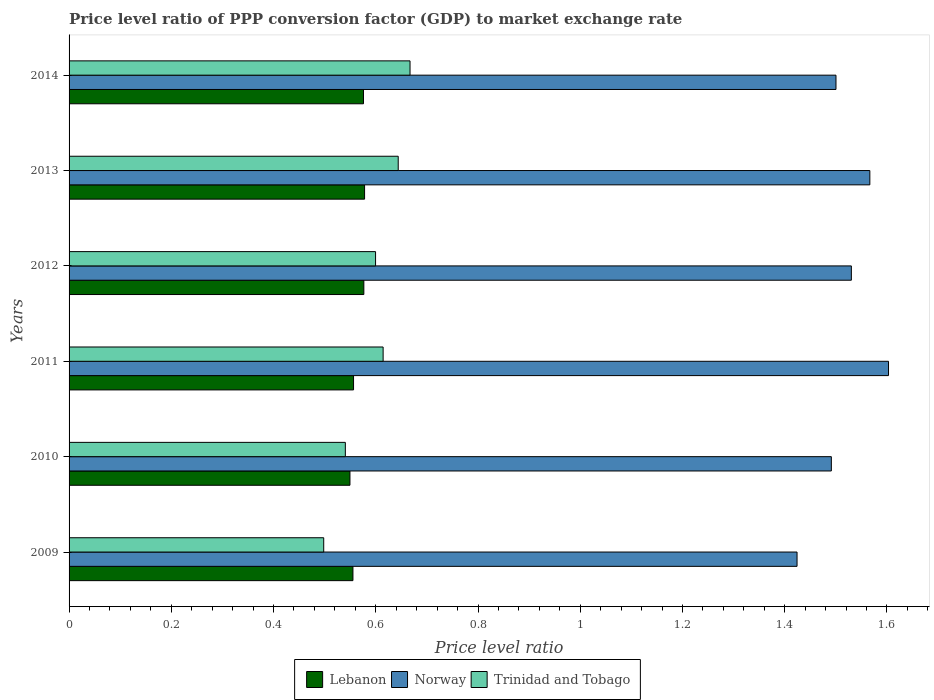How many different coloured bars are there?
Offer a very short reply. 3. How many bars are there on the 4th tick from the top?
Offer a very short reply. 3. How many bars are there on the 1st tick from the bottom?
Offer a terse response. 3. In how many cases, is the number of bars for a given year not equal to the number of legend labels?
Give a very brief answer. 0. What is the price level ratio in Norway in 2011?
Provide a short and direct response. 1.6. Across all years, what is the maximum price level ratio in Norway?
Give a very brief answer. 1.6. Across all years, what is the minimum price level ratio in Norway?
Provide a succinct answer. 1.42. What is the total price level ratio in Lebanon in the graph?
Offer a very short reply. 3.39. What is the difference between the price level ratio in Trinidad and Tobago in 2009 and that in 2012?
Keep it short and to the point. -0.1. What is the difference between the price level ratio in Norway in 2010 and the price level ratio in Trinidad and Tobago in 2012?
Ensure brevity in your answer.  0.89. What is the average price level ratio in Lebanon per year?
Your answer should be very brief. 0.57. In the year 2014, what is the difference between the price level ratio in Norway and price level ratio in Lebanon?
Keep it short and to the point. 0.92. In how many years, is the price level ratio in Norway greater than 1.36 ?
Your response must be concise. 6. What is the ratio of the price level ratio in Norway in 2009 to that in 2013?
Provide a succinct answer. 0.91. Is the price level ratio in Norway in 2009 less than that in 2014?
Offer a terse response. Yes. What is the difference between the highest and the second highest price level ratio in Norway?
Provide a short and direct response. 0.04. What is the difference between the highest and the lowest price level ratio in Trinidad and Tobago?
Provide a succinct answer. 0.17. What does the 3rd bar from the top in 2012 represents?
Your response must be concise. Lebanon. Is it the case that in every year, the sum of the price level ratio in Norway and price level ratio in Trinidad and Tobago is greater than the price level ratio in Lebanon?
Make the answer very short. Yes. How many bars are there?
Provide a short and direct response. 18. Are all the bars in the graph horizontal?
Give a very brief answer. Yes. How many years are there in the graph?
Make the answer very short. 6. Are the values on the major ticks of X-axis written in scientific E-notation?
Ensure brevity in your answer.  No. Where does the legend appear in the graph?
Offer a very short reply. Bottom center. How are the legend labels stacked?
Your response must be concise. Horizontal. What is the title of the graph?
Keep it short and to the point. Price level ratio of PPP conversion factor (GDP) to market exchange rate. Does "Swaziland" appear as one of the legend labels in the graph?
Offer a very short reply. No. What is the label or title of the X-axis?
Give a very brief answer. Price level ratio. What is the label or title of the Y-axis?
Make the answer very short. Years. What is the Price level ratio of Lebanon in 2009?
Make the answer very short. 0.56. What is the Price level ratio in Norway in 2009?
Ensure brevity in your answer.  1.42. What is the Price level ratio in Trinidad and Tobago in 2009?
Offer a very short reply. 0.5. What is the Price level ratio of Lebanon in 2010?
Provide a succinct answer. 0.55. What is the Price level ratio of Norway in 2010?
Ensure brevity in your answer.  1.49. What is the Price level ratio of Trinidad and Tobago in 2010?
Keep it short and to the point. 0.54. What is the Price level ratio of Lebanon in 2011?
Your response must be concise. 0.56. What is the Price level ratio of Norway in 2011?
Your response must be concise. 1.6. What is the Price level ratio of Trinidad and Tobago in 2011?
Offer a very short reply. 0.61. What is the Price level ratio in Lebanon in 2012?
Your answer should be compact. 0.58. What is the Price level ratio in Norway in 2012?
Offer a terse response. 1.53. What is the Price level ratio in Trinidad and Tobago in 2012?
Your answer should be compact. 0.6. What is the Price level ratio of Lebanon in 2013?
Your answer should be compact. 0.58. What is the Price level ratio in Norway in 2013?
Keep it short and to the point. 1.57. What is the Price level ratio in Trinidad and Tobago in 2013?
Provide a succinct answer. 0.64. What is the Price level ratio of Lebanon in 2014?
Provide a succinct answer. 0.58. What is the Price level ratio of Norway in 2014?
Your answer should be very brief. 1.5. What is the Price level ratio in Trinidad and Tobago in 2014?
Keep it short and to the point. 0.67. Across all years, what is the maximum Price level ratio in Lebanon?
Keep it short and to the point. 0.58. Across all years, what is the maximum Price level ratio of Norway?
Provide a succinct answer. 1.6. Across all years, what is the maximum Price level ratio in Trinidad and Tobago?
Make the answer very short. 0.67. Across all years, what is the minimum Price level ratio in Lebanon?
Ensure brevity in your answer.  0.55. Across all years, what is the minimum Price level ratio in Norway?
Give a very brief answer. 1.42. Across all years, what is the minimum Price level ratio of Trinidad and Tobago?
Make the answer very short. 0.5. What is the total Price level ratio in Lebanon in the graph?
Your answer should be very brief. 3.39. What is the total Price level ratio of Norway in the graph?
Offer a very short reply. 9.12. What is the total Price level ratio of Trinidad and Tobago in the graph?
Provide a short and direct response. 3.56. What is the difference between the Price level ratio of Lebanon in 2009 and that in 2010?
Keep it short and to the point. 0.01. What is the difference between the Price level ratio of Norway in 2009 and that in 2010?
Ensure brevity in your answer.  -0.07. What is the difference between the Price level ratio in Trinidad and Tobago in 2009 and that in 2010?
Keep it short and to the point. -0.04. What is the difference between the Price level ratio in Lebanon in 2009 and that in 2011?
Offer a terse response. -0. What is the difference between the Price level ratio in Norway in 2009 and that in 2011?
Provide a succinct answer. -0.18. What is the difference between the Price level ratio in Trinidad and Tobago in 2009 and that in 2011?
Your response must be concise. -0.12. What is the difference between the Price level ratio of Lebanon in 2009 and that in 2012?
Ensure brevity in your answer.  -0.02. What is the difference between the Price level ratio in Norway in 2009 and that in 2012?
Make the answer very short. -0.11. What is the difference between the Price level ratio in Trinidad and Tobago in 2009 and that in 2012?
Provide a succinct answer. -0.1. What is the difference between the Price level ratio of Lebanon in 2009 and that in 2013?
Provide a succinct answer. -0.02. What is the difference between the Price level ratio of Norway in 2009 and that in 2013?
Offer a terse response. -0.14. What is the difference between the Price level ratio of Trinidad and Tobago in 2009 and that in 2013?
Your answer should be compact. -0.15. What is the difference between the Price level ratio of Lebanon in 2009 and that in 2014?
Your answer should be compact. -0.02. What is the difference between the Price level ratio of Norway in 2009 and that in 2014?
Give a very brief answer. -0.08. What is the difference between the Price level ratio of Trinidad and Tobago in 2009 and that in 2014?
Provide a succinct answer. -0.17. What is the difference between the Price level ratio in Lebanon in 2010 and that in 2011?
Make the answer very short. -0.01. What is the difference between the Price level ratio in Norway in 2010 and that in 2011?
Provide a short and direct response. -0.11. What is the difference between the Price level ratio in Trinidad and Tobago in 2010 and that in 2011?
Offer a terse response. -0.07. What is the difference between the Price level ratio in Lebanon in 2010 and that in 2012?
Keep it short and to the point. -0.03. What is the difference between the Price level ratio of Norway in 2010 and that in 2012?
Give a very brief answer. -0.04. What is the difference between the Price level ratio of Trinidad and Tobago in 2010 and that in 2012?
Ensure brevity in your answer.  -0.06. What is the difference between the Price level ratio of Lebanon in 2010 and that in 2013?
Your answer should be very brief. -0.03. What is the difference between the Price level ratio of Norway in 2010 and that in 2013?
Your answer should be very brief. -0.08. What is the difference between the Price level ratio in Trinidad and Tobago in 2010 and that in 2013?
Make the answer very short. -0.1. What is the difference between the Price level ratio of Lebanon in 2010 and that in 2014?
Offer a very short reply. -0.03. What is the difference between the Price level ratio in Norway in 2010 and that in 2014?
Offer a very short reply. -0.01. What is the difference between the Price level ratio of Trinidad and Tobago in 2010 and that in 2014?
Your answer should be compact. -0.13. What is the difference between the Price level ratio of Lebanon in 2011 and that in 2012?
Provide a short and direct response. -0.02. What is the difference between the Price level ratio of Norway in 2011 and that in 2012?
Offer a very short reply. 0.07. What is the difference between the Price level ratio in Trinidad and Tobago in 2011 and that in 2012?
Your answer should be compact. 0.01. What is the difference between the Price level ratio of Lebanon in 2011 and that in 2013?
Offer a very short reply. -0.02. What is the difference between the Price level ratio of Norway in 2011 and that in 2013?
Your response must be concise. 0.04. What is the difference between the Price level ratio of Trinidad and Tobago in 2011 and that in 2013?
Provide a succinct answer. -0.03. What is the difference between the Price level ratio in Lebanon in 2011 and that in 2014?
Ensure brevity in your answer.  -0.02. What is the difference between the Price level ratio of Norway in 2011 and that in 2014?
Your answer should be very brief. 0.1. What is the difference between the Price level ratio of Trinidad and Tobago in 2011 and that in 2014?
Offer a very short reply. -0.05. What is the difference between the Price level ratio of Lebanon in 2012 and that in 2013?
Your response must be concise. -0. What is the difference between the Price level ratio in Norway in 2012 and that in 2013?
Offer a very short reply. -0.04. What is the difference between the Price level ratio of Trinidad and Tobago in 2012 and that in 2013?
Give a very brief answer. -0.04. What is the difference between the Price level ratio in Lebanon in 2012 and that in 2014?
Keep it short and to the point. 0. What is the difference between the Price level ratio in Norway in 2012 and that in 2014?
Make the answer very short. 0.03. What is the difference between the Price level ratio of Trinidad and Tobago in 2012 and that in 2014?
Keep it short and to the point. -0.07. What is the difference between the Price level ratio of Lebanon in 2013 and that in 2014?
Provide a succinct answer. 0. What is the difference between the Price level ratio of Norway in 2013 and that in 2014?
Offer a terse response. 0.07. What is the difference between the Price level ratio of Trinidad and Tobago in 2013 and that in 2014?
Your response must be concise. -0.02. What is the difference between the Price level ratio of Lebanon in 2009 and the Price level ratio of Norway in 2010?
Provide a succinct answer. -0.94. What is the difference between the Price level ratio of Lebanon in 2009 and the Price level ratio of Trinidad and Tobago in 2010?
Your answer should be very brief. 0.01. What is the difference between the Price level ratio of Norway in 2009 and the Price level ratio of Trinidad and Tobago in 2010?
Provide a succinct answer. 0.88. What is the difference between the Price level ratio in Lebanon in 2009 and the Price level ratio in Norway in 2011?
Provide a succinct answer. -1.05. What is the difference between the Price level ratio in Lebanon in 2009 and the Price level ratio in Trinidad and Tobago in 2011?
Offer a terse response. -0.06. What is the difference between the Price level ratio in Norway in 2009 and the Price level ratio in Trinidad and Tobago in 2011?
Offer a terse response. 0.81. What is the difference between the Price level ratio of Lebanon in 2009 and the Price level ratio of Norway in 2012?
Your response must be concise. -0.98. What is the difference between the Price level ratio of Lebanon in 2009 and the Price level ratio of Trinidad and Tobago in 2012?
Offer a very short reply. -0.04. What is the difference between the Price level ratio in Norway in 2009 and the Price level ratio in Trinidad and Tobago in 2012?
Keep it short and to the point. 0.82. What is the difference between the Price level ratio of Lebanon in 2009 and the Price level ratio of Norway in 2013?
Ensure brevity in your answer.  -1.01. What is the difference between the Price level ratio in Lebanon in 2009 and the Price level ratio in Trinidad and Tobago in 2013?
Offer a terse response. -0.09. What is the difference between the Price level ratio in Norway in 2009 and the Price level ratio in Trinidad and Tobago in 2013?
Your response must be concise. 0.78. What is the difference between the Price level ratio of Lebanon in 2009 and the Price level ratio of Norway in 2014?
Make the answer very short. -0.94. What is the difference between the Price level ratio in Lebanon in 2009 and the Price level ratio in Trinidad and Tobago in 2014?
Your answer should be compact. -0.11. What is the difference between the Price level ratio of Norway in 2009 and the Price level ratio of Trinidad and Tobago in 2014?
Offer a terse response. 0.76. What is the difference between the Price level ratio of Lebanon in 2010 and the Price level ratio of Norway in 2011?
Your response must be concise. -1.05. What is the difference between the Price level ratio of Lebanon in 2010 and the Price level ratio of Trinidad and Tobago in 2011?
Give a very brief answer. -0.06. What is the difference between the Price level ratio in Norway in 2010 and the Price level ratio in Trinidad and Tobago in 2011?
Your answer should be very brief. 0.88. What is the difference between the Price level ratio of Lebanon in 2010 and the Price level ratio of Norway in 2012?
Offer a terse response. -0.98. What is the difference between the Price level ratio of Lebanon in 2010 and the Price level ratio of Trinidad and Tobago in 2012?
Offer a very short reply. -0.05. What is the difference between the Price level ratio of Norway in 2010 and the Price level ratio of Trinidad and Tobago in 2012?
Make the answer very short. 0.89. What is the difference between the Price level ratio of Lebanon in 2010 and the Price level ratio of Norway in 2013?
Make the answer very short. -1.02. What is the difference between the Price level ratio in Lebanon in 2010 and the Price level ratio in Trinidad and Tobago in 2013?
Your response must be concise. -0.09. What is the difference between the Price level ratio in Norway in 2010 and the Price level ratio in Trinidad and Tobago in 2013?
Offer a very short reply. 0.85. What is the difference between the Price level ratio in Lebanon in 2010 and the Price level ratio in Norway in 2014?
Your answer should be compact. -0.95. What is the difference between the Price level ratio of Lebanon in 2010 and the Price level ratio of Trinidad and Tobago in 2014?
Your answer should be compact. -0.12. What is the difference between the Price level ratio in Norway in 2010 and the Price level ratio in Trinidad and Tobago in 2014?
Ensure brevity in your answer.  0.82. What is the difference between the Price level ratio in Lebanon in 2011 and the Price level ratio in Norway in 2012?
Make the answer very short. -0.97. What is the difference between the Price level ratio of Lebanon in 2011 and the Price level ratio of Trinidad and Tobago in 2012?
Your response must be concise. -0.04. What is the difference between the Price level ratio of Lebanon in 2011 and the Price level ratio of Norway in 2013?
Keep it short and to the point. -1.01. What is the difference between the Price level ratio in Lebanon in 2011 and the Price level ratio in Trinidad and Tobago in 2013?
Offer a terse response. -0.09. What is the difference between the Price level ratio in Norway in 2011 and the Price level ratio in Trinidad and Tobago in 2013?
Offer a very short reply. 0.96. What is the difference between the Price level ratio of Lebanon in 2011 and the Price level ratio of Norway in 2014?
Your response must be concise. -0.94. What is the difference between the Price level ratio of Lebanon in 2011 and the Price level ratio of Trinidad and Tobago in 2014?
Your answer should be compact. -0.11. What is the difference between the Price level ratio in Norway in 2011 and the Price level ratio in Trinidad and Tobago in 2014?
Your answer should be compact. 0.94. What is the difference between the Price level ratio of Lebanon in 2012 and the Price level ratio of Norway in 2013?
Your response must be concise. -0.99. What is the difference between the Price level ratio of Lebanon in 2012 and the Price level ratio of Trinidad and Tobago in 2013?
Provide a short and direct response. -0.07. What is the difference between the Price level ratio in Norway in 2012 and the Price level ratio in Trinidad and Tobago in 2013?
Make the answer very short. 0.89. What is the difference between the Price level ratio of Lebanon in 2012 and the Price level ratio of Norway in 2014?
Offer a terse response. -0.92. What is the difference between the Price level ratio of Lebanon in 2012 and the Price level ratio of Trinidad and Tobago in 2014?
Make the answer very short. -0.09. What is the difference between the Price level ratio in Norway in 2012 and the Price level ratio in Trinidad and Tobago in 2014?
Give a very brief answer. 0.86. What is the difference between the Price level ratio of Lebanon in 2013 and the Price level ratio of Norway in 2014?
Your answer should be compact. -0.92. What is the difference between the Price level ratio of Lebanon in 2013 and the Price level ratio of Trinidad and Tobago in 2014?
Give a very brief answer. -0.09. What is the difference between the Price level ratio of Norway in 2013 and the Price level ratio of Trinidad and Tobago in 2014?
Your response must be concise. 0.9. What is the average Price level ratio of Lebanon per year?
Provide a short and direct response. 0.57. What is the average Price level ratio in Norway per year?
Offer a terse response. 1.52. What is the average Price level ratio in Trinidad and Tobago per year?
Keep it short and to the point. 0.59. In the year 2009, what is the difference between the Price level ratio in Lebanon and Price level ratio in Norway?
Your answer should be very brief. -0.87. In the year 2009, what is the difference between the Price level ratio of Lebanon and Price level ratio of Trinidad and Tobago?
Provide a succinct answer. 0.06. In the year 2009, what is the difference between the Price level ratio of Norway and Price level ratio of Trinidad and Tobago?
Your answer should be very brief. 0.93. In the year 2010, what is the difference between the Price level ratio in Lebanon and Price level ratio in Norway?
Offer a very short reply. -0.94. In the year 2010, what is the difference between the Price level ratio in Lebanon and Price level ratio in Trinidad and Tobago?
Your answer should be compact. 0.01. In the year 2010, what is the difference between the Price level ratio of Norway and Price level ratio of Trinidad and Tobago?
Offer a terse response. 0.95. In the year 2011, what is the difference between the Price level ratio in Lebanon and Price level ratio in Norway?
Offer a very short reply. -1.05. In the year 2011, what is the difference between the Price level ratio of Lebanon and Price level ratio of Trinidad and Tobago?
Provide a short and direct response. -0.06. In the year 2011, what is the difference between the Price level ratio of Norway and Price level ratio of Trinidad and Tobago?
Provide a succinct answer. 0.99. In the year 2012, what is the difference between the Price level ratio of Lebanon and Price level ratio of Norway?
Provide a short and direct response. -0.95. In the year 2012, what is the difference between the Price level ratio in Lebanon and Price level ratio in Trinidad and Tobago?
Give a very brief answer. -0.02. In the year 2012, what is the difference between the Price level ratio of Norway and Price level ratio of Trinidad and Tobago?
Your answer should be compact. 0.93. In the year 2013, what is the difference between the Price level ratio of Lebanon and Price level ratio of Norway?
Your response must be concise. -0.99. In the year 2013, what is the difference between the Price level ratio of Lebanon and Price level ratio of Trinidad and Tobago?
Make the answer very short. -0.07. In the year 2013, what is the difference between the Price level ratio of Norway and Price level ratio of Trinidad and Tobago?
Make the answer very short. 0.92. In the year 2014, what is the difference between the Price level ratio in Lebanon and Price level ratio in Norway?
Keep it short and to the point. -0.92. In the year 2014, what is the difference between the Price level ratio in Lebanon and Price level ratio in Trinidad and Tobago?
Ensure brevity in your answer.  -0.09. What is the ratio of the Price level ratio in Lebanon in 2009 to that in 2010?
Your response must be concise. 1.01. What is the ratio of the Price level ratio in Norway in 2009 to that in 2010?
Your response must be concise. 0.95. What is the ratio of the Price level ratio in Trinidad and Tobago in 2009 to that in 2010?
Offer a very short reply. 0.92. What is the ratio of the Price level ratio of Norway in 2009 to that in 2011?
Offer a very short reply. 0.89. What is the ratio of the Price level ratio in Trinidad and Tobago in 2009 to that in 2011?
Keep it short and to the point. 0.81. What is the ratio of the Price level ratio of Lebanon in 2009 to that in 2012?
Your response must be concise. 0.96. What is the ratio of the Price level ratio of Norway in 2009 to that in 2012?
Offer a terse response. 0.93. What is the ratio of the Price level ratio of Trinidad and Tobago in 2009 to that in 2012?
Keep it short and to the point. 0.83. What is the ratio of the Price level ratio in Lebanon in 2009 to that in 2013?
Your answer should be very brief. 0.96. What is the ratio of the Price level ratio in Norway in 2009 to that in 2013?
Offer a very short reply. 0.91. What is the ratio of the Price level ratio of Trinidad and Tobago in 2009 to that in 2013?
Give a very brief answer. 0.77. What is the ratio of the Price level ratio in Lebanon in 2009 to that in 2014?
Ensure brevity in your answer.  0.96. What is the ratio of the Price level ratio in Norway in 2009 to that in 2014?
Keep it short and to the point. 0.95. What is the ratio of the Price level ratio in Trinidad and Tobago in 2009 to that in 2014?
Keep it short and to the point. 0.75. What is the ratio of the Price level ratio in Lebanon in 2010 to that in 2011?
Ensure brevity in your answer.  0.99. What is the ratio of the Price level ratio of Norway in 2010 to that in 2011?
Give a very brief answer. 0.93. What is the ratio of the Price level ratio of Trinidad and Tobago in 2010 to that in 2011?
Make the answer very short. 0.88. What is the ratio of the Price level ratio in Lebanon in 2010 to that in 2012?
Your response must be concise. 0.95. What is the ratio of the Price level ratio of Norway in 2010 to that in 2012?
Keep it short and to the point. 0.97. What is the ratio of the Price level ratio in Trinidad and Tobago in 2010 to that in 2012?
Your answer should be very brief. 0.9. What is the ratio of the Price level ratio in Lebanon in 2010 to that in 2013?
Offer a terse response. 0.95. What is the ratio of the Price level ratio in Norway in 2010 to that in 2013?
Provide a succinct answer. 0.95. What is the ratio of the Price level ratio of Trinidad and Tobago in 2010 to that in 2013?
Ensure brevity in your answer.  0.84. What is the ratio of the Price level ratio of Lebanon in 2010 to that in 2014?
Provide a succinct answer. 0.95. What is the ratio of the Price level ratio of Norway in 2010 to that in 2014?
Provide a succinct answer. 0.99. What is the ratio of the Price level ratio in Trinidad and Tobago in 2010 to that in 2014?
Your answer should be compact. 0.81. What is the ratio of the Price level ratio of Lebanon in 2011 to that in 2012?
Your answer should be very brief. 0.97. What is the ratio of the Price level ratio in Norway in 2011 to that in 2012?
Offer a terse response. 1.05. What is the ratio of the Price level ratio of Trinidad and Tobago in 2011 to that in 2012?
Ensure brevity in your answer.  1.02. What is the ratio of the Price level ratio of Lebanon in 2011 to that in 2013?
Make the answer very short. 0.96. What is the ratio of the Price level ratio of Norway in 2011 to that in 2013?
Keep it short and to the point. 1.02. What is the ratio of the Price level ratio of Trinidad and Tobago in 2011 to that in 2013?
Your answer should be very brief. 0.95. What is the ratio of the Price level ratio in Lebanon in 2011 to that in 2014?
Provide a succinct answer. 0.97. What is the ratio of the Price level ratio of Norway in 2011 to that in 2014?
Provide a short and direct response. 1.07. What is the ratio of the Price level ratio of Trinidad and Tobago in 2011 to that in 2014?
Offer a terse response. 0.92. What is the ratio of the Price level ratio of Lebanon in 2012 to that in 2013?
Keep it short and to the point. 1. What is the ratio of the Price level ratio of Norway in 2012 to that in 2013?
Provide a short and direct response. 0.98. What is the ratio of the Price level ratio in Trinidad and Tobago in 2012 to that in 2013?
Your answer should be compact. 0.93. What is the ratio of the Price level ratio of Lebanon in 2012 to that in 2014?
Ensure brevity in your answer.  1. What is the ratio of the Price level ratio in Trinidad and Tobago in 2012 to that in 2014?
Keep it short and to the point. 0.9. What is the ratio of the Price level ratio of Norway in 2013 to that in 2014?
Keep it short and to the point. 1.04. What is the ratio of the Price level ratio of Trinidad and Tobago in 2013 to that in 2014?
Provide a short and direct response. 0.97. What is the difference between the highest and the second highest Price level ratio of Lebanon?
Provide a short and direct response. 0. What is the difference between the highest and the second highest Price level ratio in Norway?
Your answer should be compact. 0.04. What is the difference between the highest and the second highest Price level ratio of Trinidad and Tobago?
Keep it short and to the point. 0.02. What is the difference between the highest and the lowest Price level ratio in Lebanon?
Your answer should be very brief. 0.03. What is the difference between the highest and the lowest Price level ratio in Norway?
Ensure brevity in your answer.  0.18. What is the difference between the highest and the lowest Price level ratio in Trinidad and Tobago?
Offer a very short reply. 0.17. 